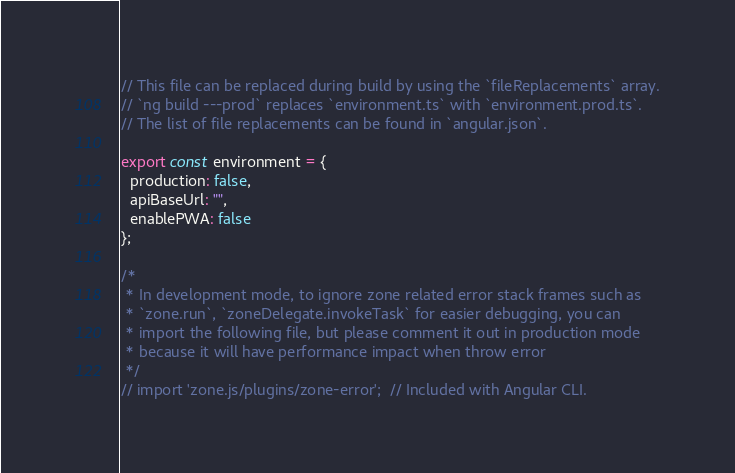<code> <loc_0><loc_0><loc_500><loc_500><_TypeScript_>// This file can be replaced during build by using the `fileReplacements` array.
// `ng build ---prod` replaces `environment.ts` with `environment.prod.ts`.
// The list of file replacements can be found in `angular.json`.

export const environment = {
  production: false,
  apiBaseUrl: "",
  enablePWA: false
};

/*
 * In development mode, to ignore zone related error stack frames such as
 * `zone.run`, `zoneDelegate.invokeTask` for easier debugging, you can
 * import the following file, but please comment it out in production mode
 * because it will have performance impact when throw error
 */
// import 'zone.js/plugins/zone-error';  // Included with Angular CLI.
</code> 